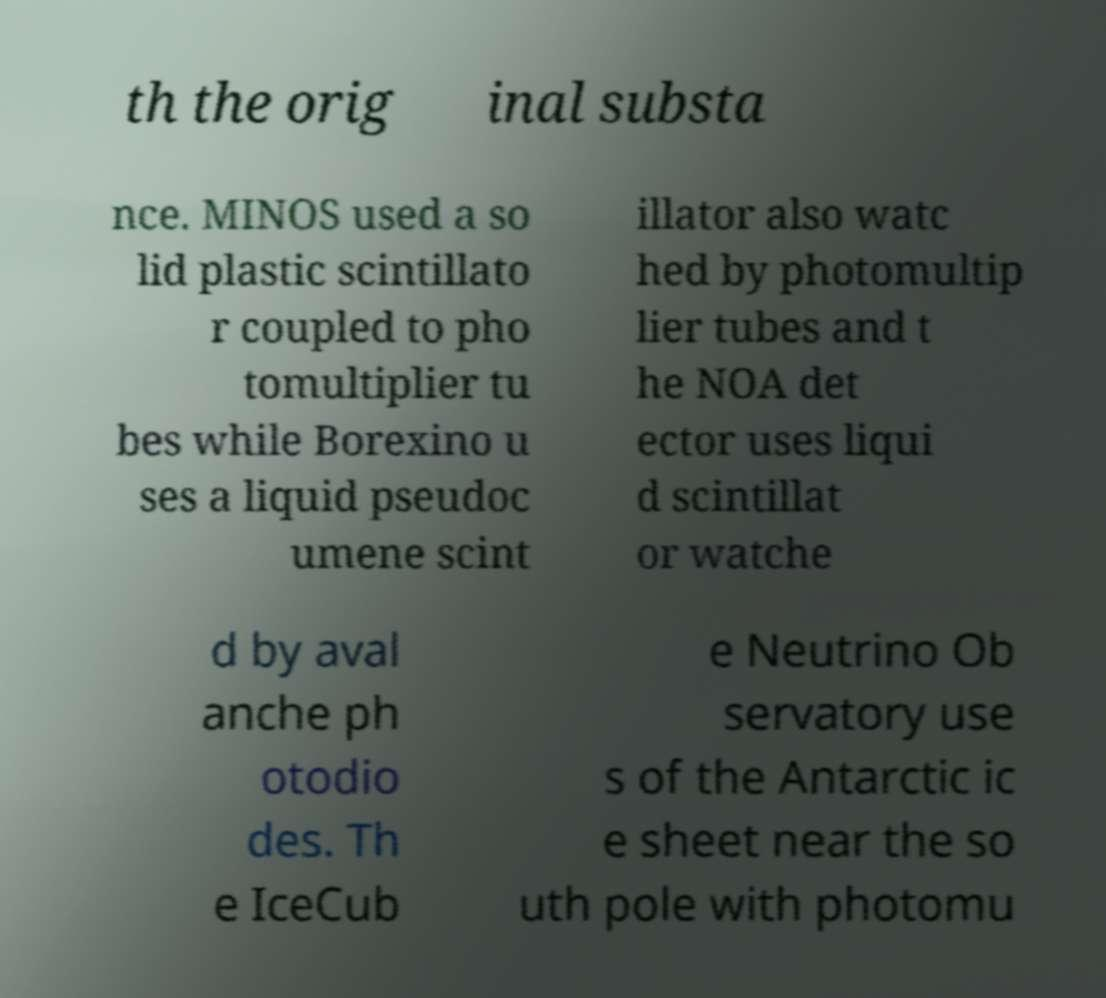Can you read and provide the text displayed in the image?This photo seems to have some interesting text. Can you extract and type it out for me? th the orig inal substa nce. MINOS used a so lid plastic scintillato r coupled to pho tomultiplier tu bes while Borexino u ses a liquid pseudoc umene scint illator also watc hed by photomultip lier tubes and t he NOA det ector uses liqui d scintillat or watche d by aval anche ph otodio des. Th e IceCub e Neutrino Ob servatory use s of the Antarctic ic e sheet near the so uth pole with photomu 